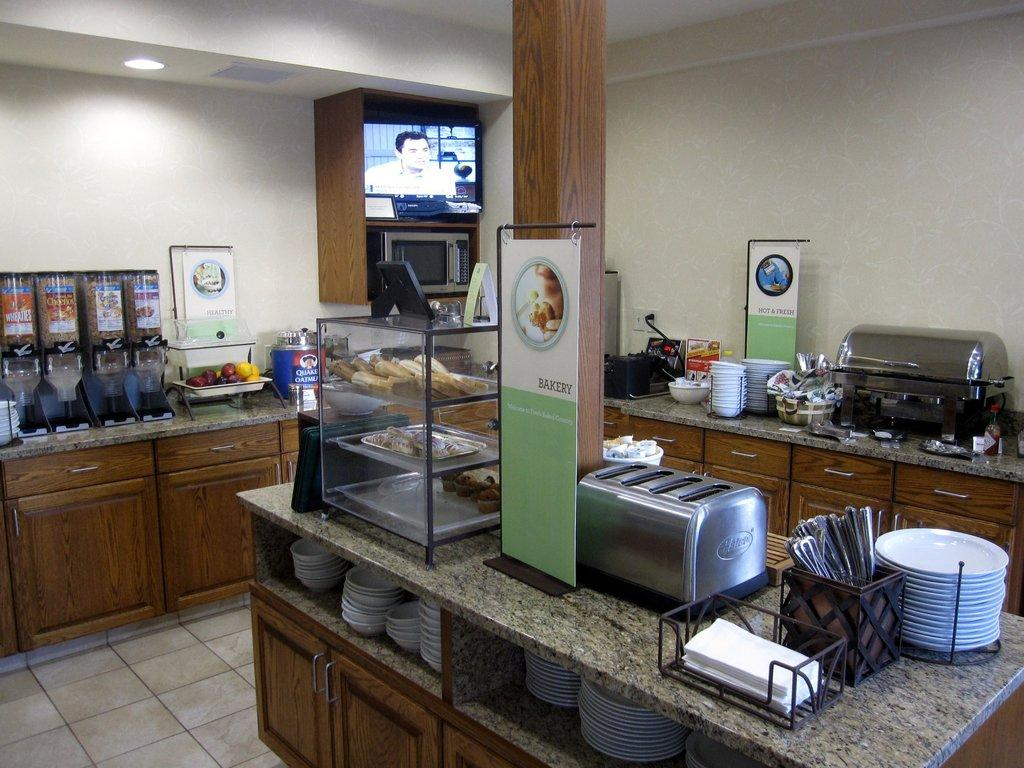Provide a one-sentence caption for the provided image. A restaurant's self serve area has a station for bakery items, hot and fresh options and healthy choices. 